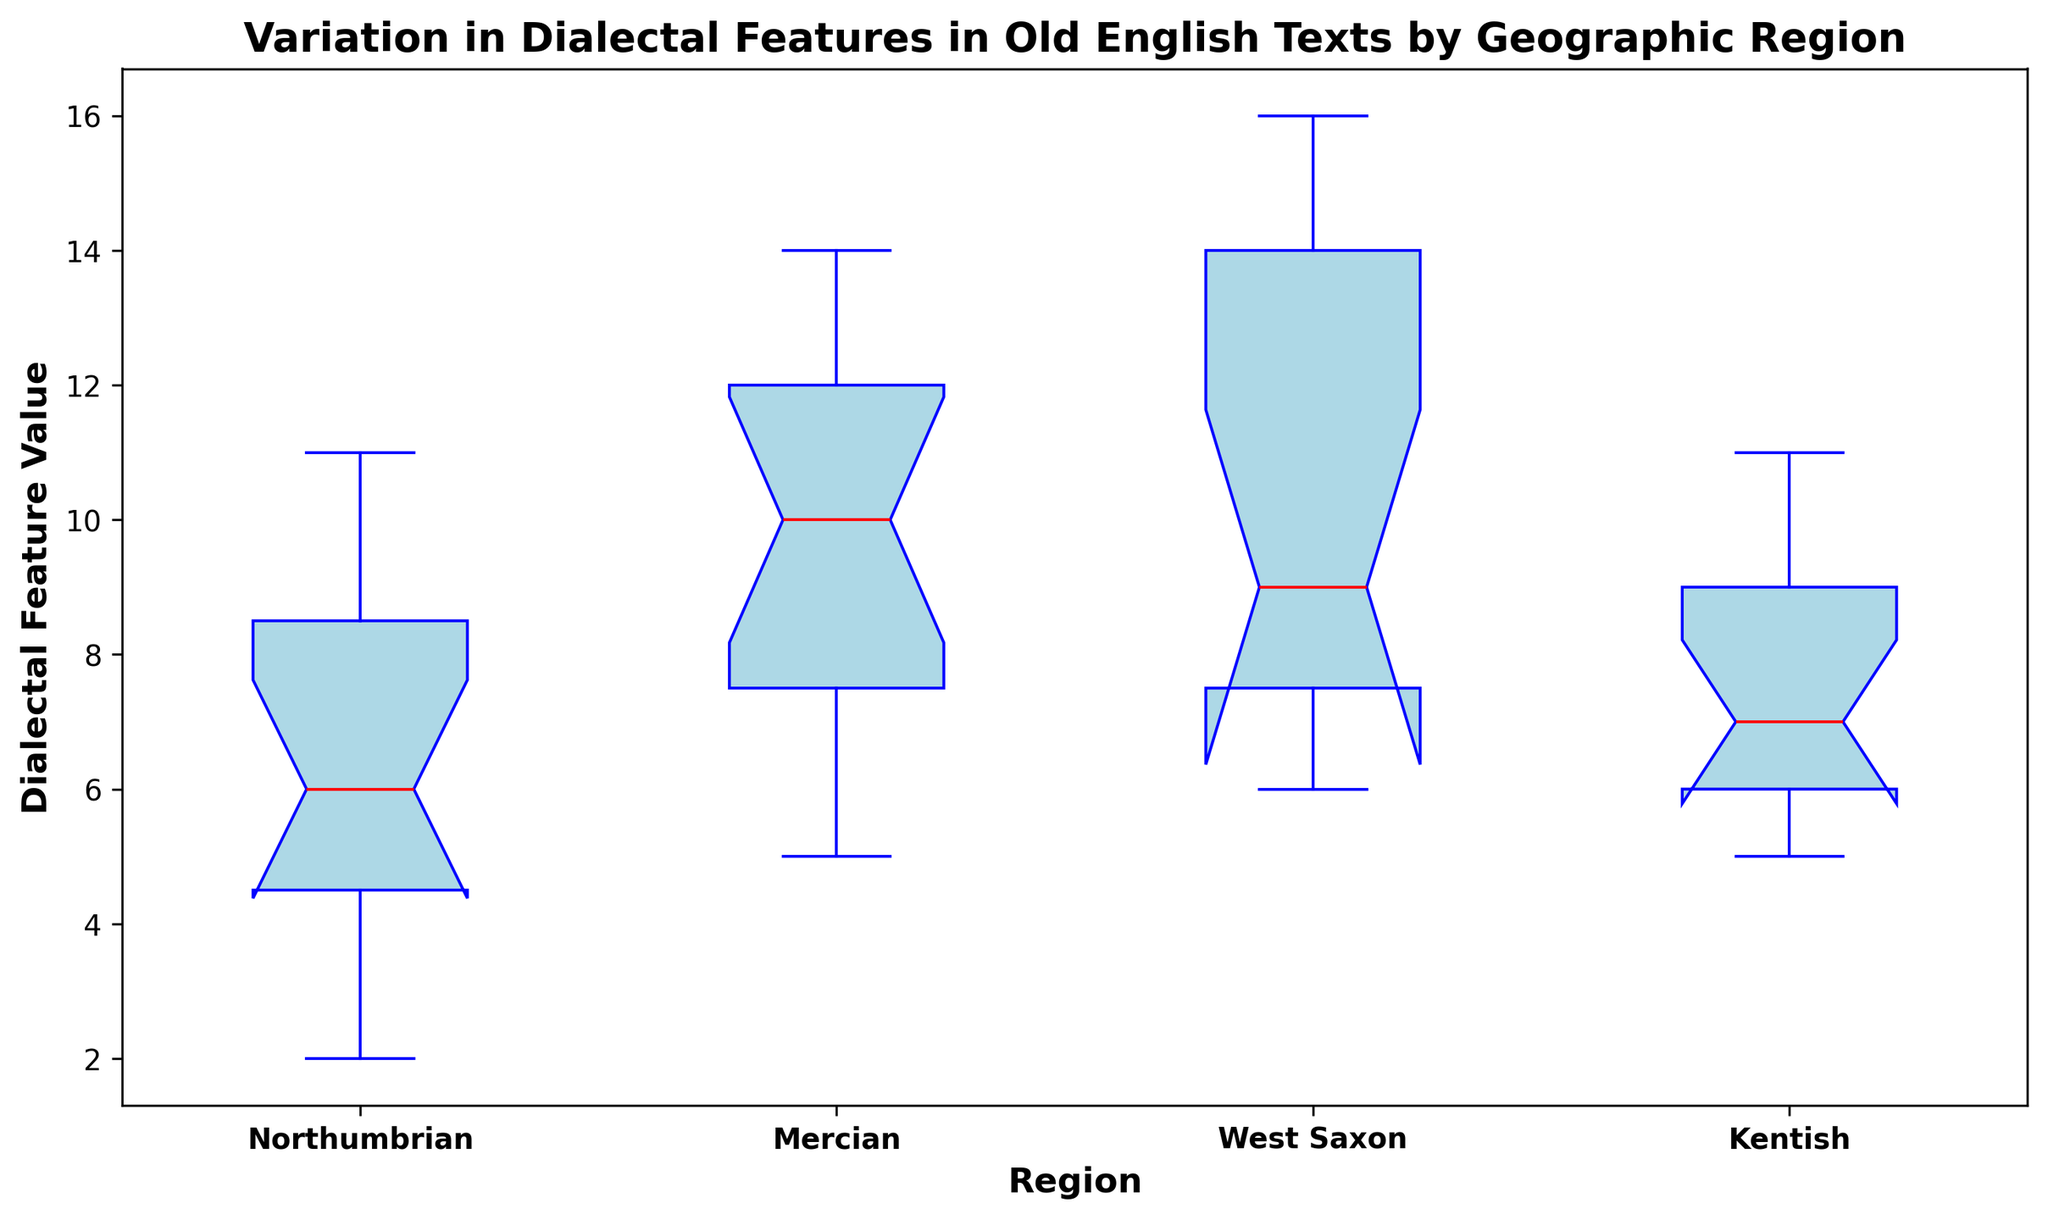What is the median value for West Saxon region? Looking at the box plot, locate the box corresponding to the West Saxon region and find the red line inside the box. This red line represents the median value.
Answer: 8 Which region displays the most variation in dialectal features? To find the region with the most variation, look at the range of the box plots across all regions. The length of the box and the whiskers represent the spread of the data. The longer the box and whiskers, the more variation.
Answer: West Saxon Compare the median values of Northumbrian and Mercian regions. Which one is higher? Locate the median values (red lines) for both Northumbrian and Mercian in their respective box plots. Compare their positions along the y-axis.
Answer: Mercian Which region has the smallest interquartile range (IQR) for dialectal features? The IQR is represented by the height of the box. The smallest IQR will be the box with the smallest height. Compare the heights of all the boxes to find the smallest one.
Answer: Northumbrian Does Kentish show more variability in dialectal features than Northumbrian? Look at the length of the box and whiskers for both Kentish and Northumbrian. Longer boxes and whiskers indicate more variability. Compare the two regions.
Answer: Yes What is the minimum value observed in Mercian? Find the lowest point of the whiskers extending from the box plot for the Mercian region. This point represents the minimum value.
Answer: 5 Rank the median values of all regions from highest to lowest. Observe the median values (red lines in the box) in each region’s box plot. Rank them from the highest to the lowest.
Answer: West Saxon, Mercian, Kentish, Northumbrian Is there any overlap in the interquartile ranges of Northumbrian and West Saxon? The interquartile range is represented by the box itself. Check if the boxes of Northumbrian and West Saxon overlap along the y-axis.
Answer: No By how much does the maximum value in Kentish exceed the median value in Northumbrian? Find the maximum value in the Kentish region (top whisker) and the median value in the Northumbrian region (red line inside the box). Subtract the median value from the maximum value.
Answer: 6 Is there an outlier in any of the regions? Look for any points (usually represented by dots) outside the whiskers of any of the box plots. Outliers are individual data points that fall outside the typical range.
Answer: No 